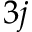<formula> <loc_0><loc_0><loc_500><loc_500>3 j</formula> 